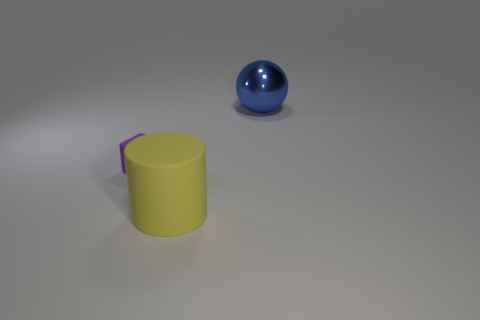How many blue balls are the same size as the blue shiny object?
Provide a short and direct response. 0. There is a big thing in front of the big blue shiny object; are there any purple matte things in front of it?
Offer a terse response. No. How many things are either matte things that are in front of the cube or small gray balls?
Your response must be concise. 1. How many green balls are there?
Provide a short and direct response. 0. The yellow thing that is made of the same material as the small purple block is what shape?
Provide a short and direct response. Cylinder. There is a rubber object behind the large object on the left side of the large metallic thing; what size is it?
Your answer should be compact. Small. How many things are either large things that are behind the tiny purple thing or objects in front of the large blue metal object?
Your response must be concise. 3. Are there fewer large yellow things than cyan cylinders?
Ensure brevity in your answer.  No. How many objects are yellow blocks or blue things?
Keep it short and to the point. 1. Is the shape of the large blue shiny thing the same as the yellow rubber thing?
Offer a terse response. No. 